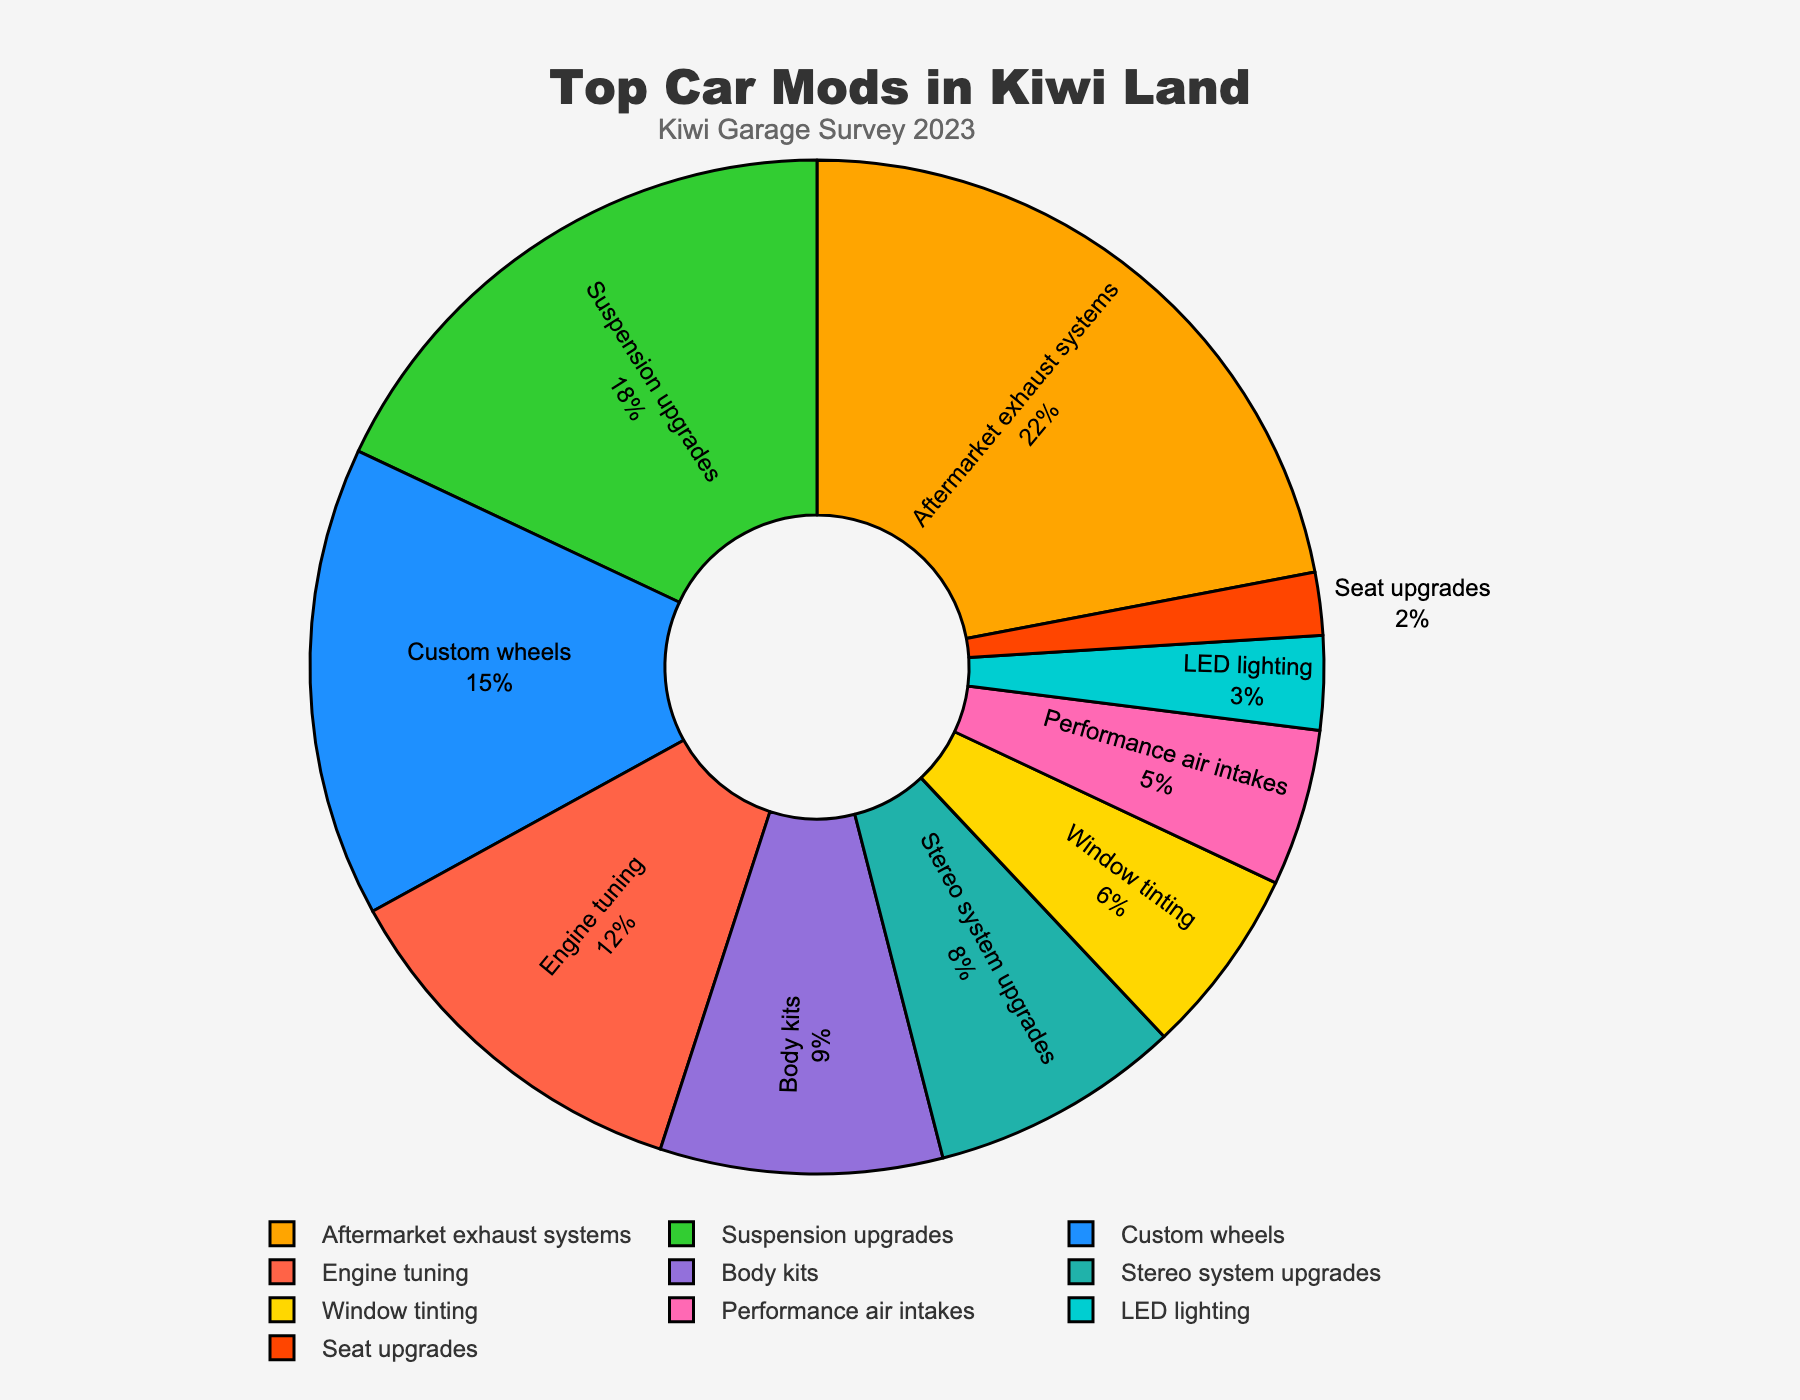Which modification is the most popular among Kiwi enthusiasts? The modification with the highest percentage in the pie chart is the most popular. In this case, "Aftermarket exhaust systems" has the highest percentage at 22%.
Answer: Aftermarket exhaust systems Which modification has the lowest percentage? The modification with the lowest percentage in the pie chart is "Seat upgrades", which stands at 2%.
Answer: Seat upgrades What is the combined percentage of suspension upgrades and custom wheels? Add the percentages of "Suspension upgrades" and "Custom wheels". Suspension upgrades have 18% and custom wheels have 15%, so the combined percentage is 18% + 15% = 33%.
Answer: 33% Are body kits more popular than engine tuning? By how much? Compare the percentages of body kits and engine tuning. Body kits have 9% while engine tuning has 12%. Engine tuning is more popular than body kits by 12% - 9% = 3%.
Answer: No, engine tuning is more popular by 3% What is the percentage difference between LED lighting and stereo system upgrades? Subtract the percentage of LED lighting from that of stereo system upgrades. Stereo system upgrades have 8% and LED lighting has 3%, so the difference is 8% - 3% = 5%.
Answer: 5% Which modifications together make up over half of the total percentage? Identify the modifications that, when their percentages are added together, exceed 50%. Starting from the highest: aftermarket exhaust systems (22%), suspension upgrades (18%), custom wheels (15%). The total is 22% + 18% + 15% = 55%. These three combined exceed half (50%) of the total.
Answer: Aftermarket exhaust systems, suspension upgrades, and custom wheels How does engine tuning compare to window tinting in terms of popularity? Compare the percentages of engine tuning and window tinting. Engine tuning has 12%, whereas window tinting has 6%. Engine tuning has double the popularity of window tinting.
Answer: Engine tuning is twice as popular Which modification associated with audio improvement has a higher percentage? Compare the percentages of modifications associated with audio improvement: stereo system upgrades and LED lighting. Stereo system upgrades have 8%, which is higher than LED lighting at 3%.
Answer: Stereo system upgrades 